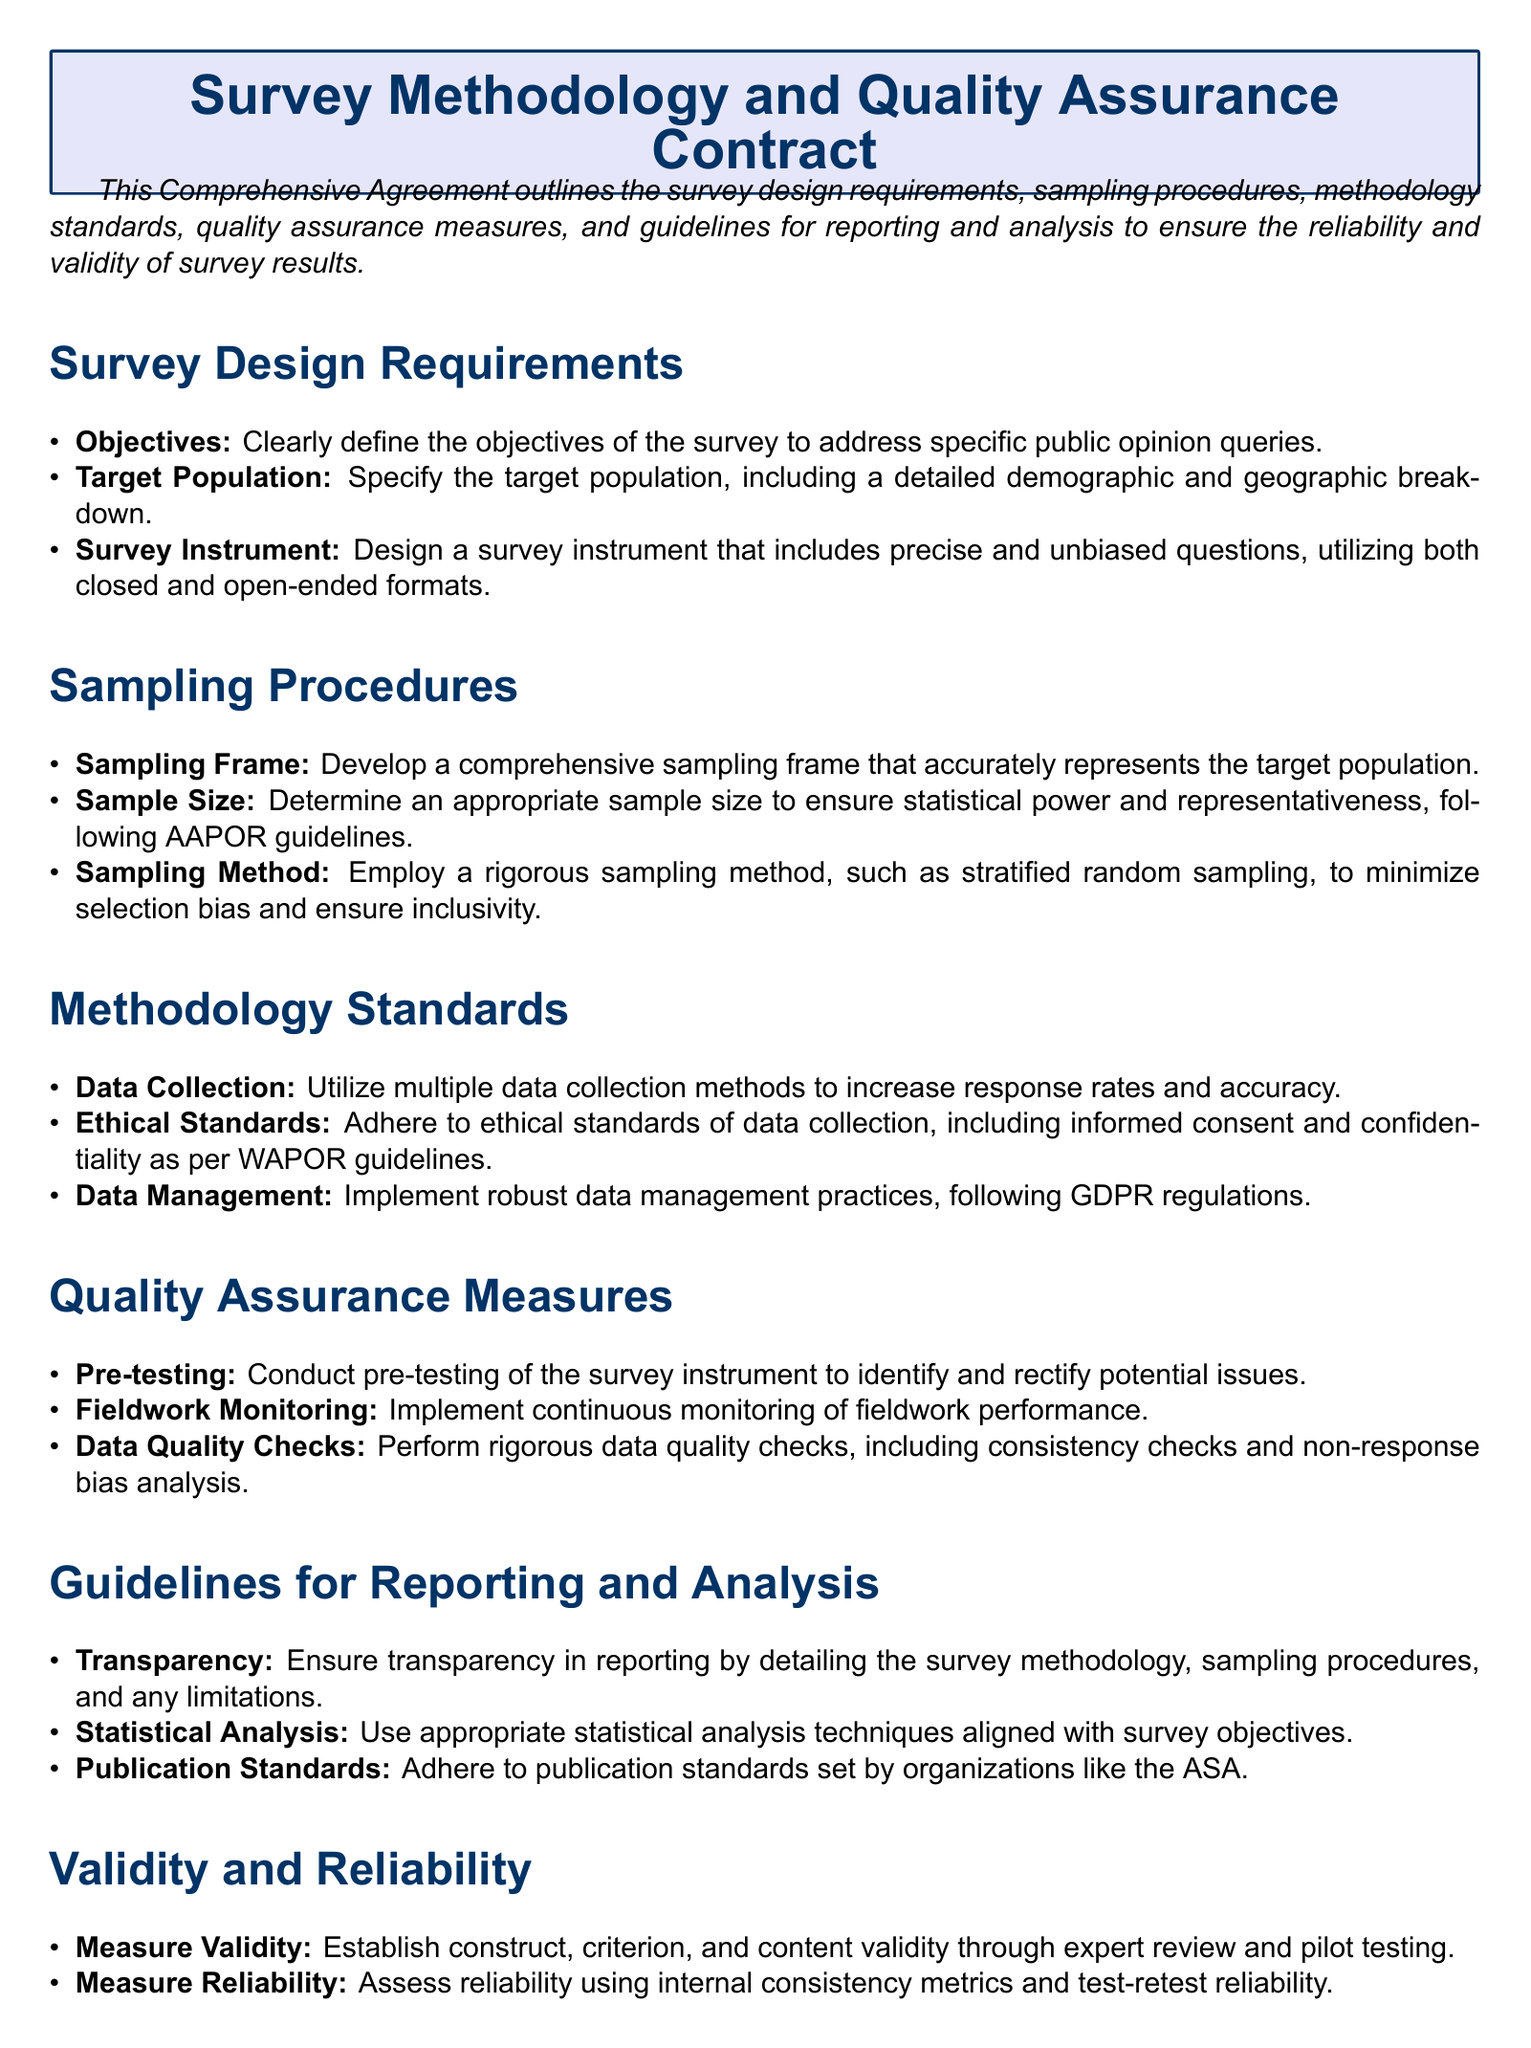What are the survey design requirements? The survey design requirements are outlined in a specific section that details objectives, target population, and survey instrument.
Answer: Objectives, Target Population, Survey Instrument What sampling method is recommended? The document suggests employing a rigorous sampling method specifically to minimize selection bias.
Answer: Stratified random sampling What is the purpose of pre-testing? Pre-testing is conducted to identify and rectify potential issues in the survey instrument before full deployment.
Answer: Identify and rectify potential issues Which ethical standards must be adhered to? The document references adherence to ethical standards including informed consent and confidentiality guidelines.
Answer: Informed consent and confidentiality What guidelines are emphasized for analysis? The guidelines for reporting and analysis include ensuring transparency and using appropriate statistical analysis techniques.
Answer: Transparency, Statistical Analysis What must be established to measure validity? The document states that construct, criterion, and content validity must be established through expert review.
Answer: Expert review and pilot testing How is reliability assessed? Reliability is assessed using specific methods mentioned in the document.
Answer: Internal consistency metrics and test-retest reliability 